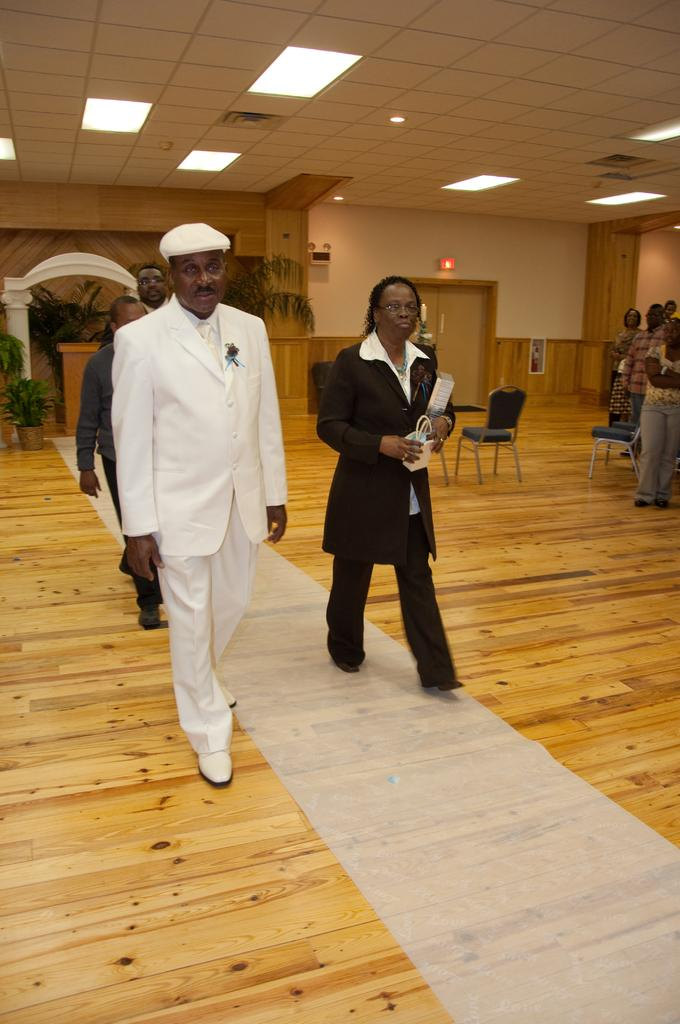What type of surface are the persons standing on in the image? The persons are standing on a wooden floor. What type of lighting is present in the background of the image? There are electric lights in the background. What architectural features can be seen in the background? There are doors in the background. What type of signs are visible in the background? There are sign boards in the background. What type of vegetation is present in the background? There are house plants in the background. What type of furniture is visible in the background? There are chairs in the background. What type of heat source is visible in the image? There is no heat source visible in the image. What type of bucket can be seen being used by the persons in the image? There is no bucket present in the image. 